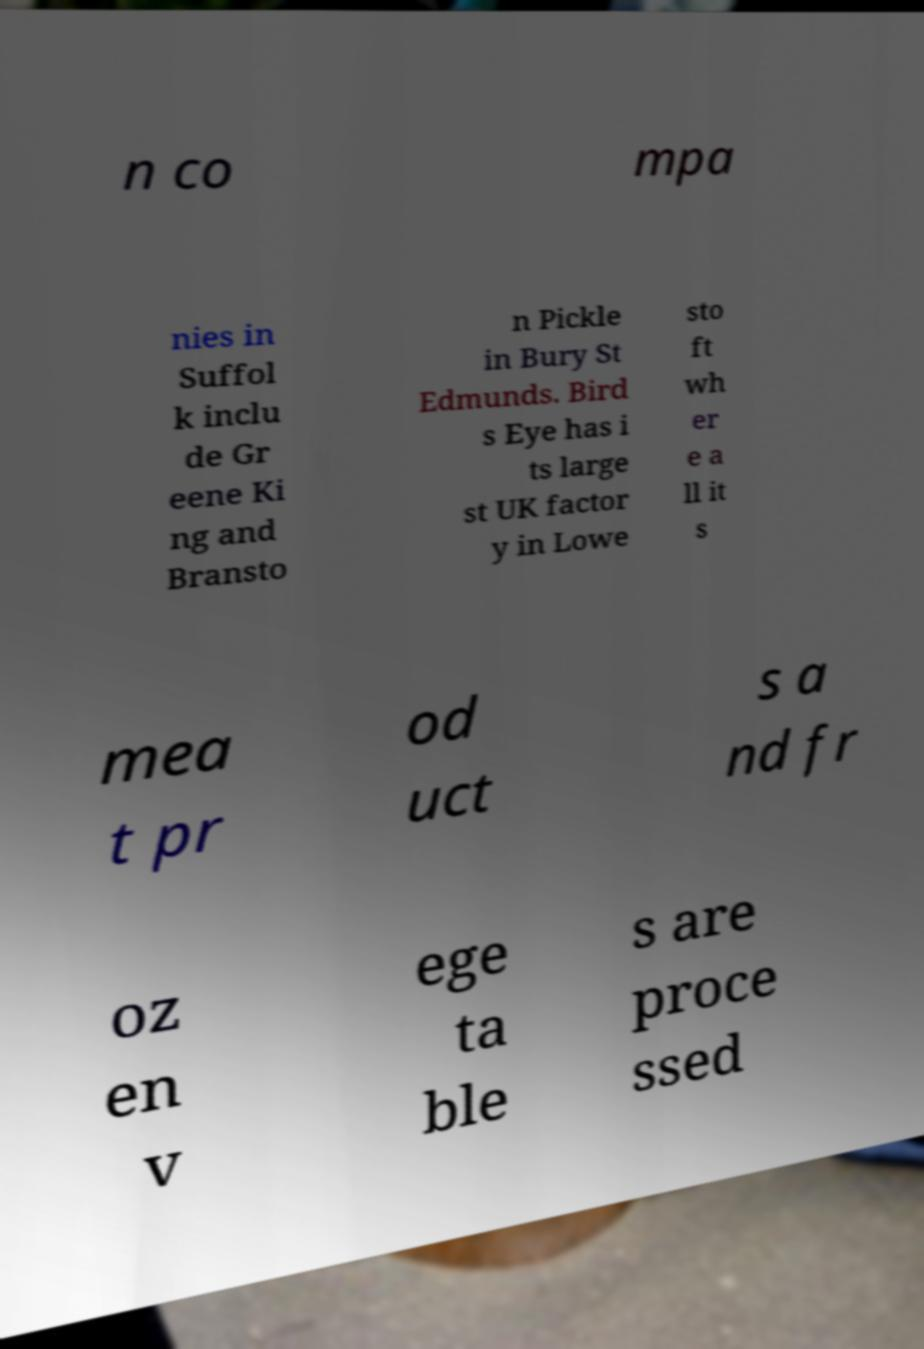Could you extract and type out the text from this image? n co mpa nies in Suffol k inclu de Gr eene Ki ng and Bransto n Pickle in Bury St Edmunds. Bird s Eye has i ts large st UK factor y in Lowe sto ft wh er e a ll it s mea t pr od uct s a nd fr oz en v ege ta ble s are proce ssed 